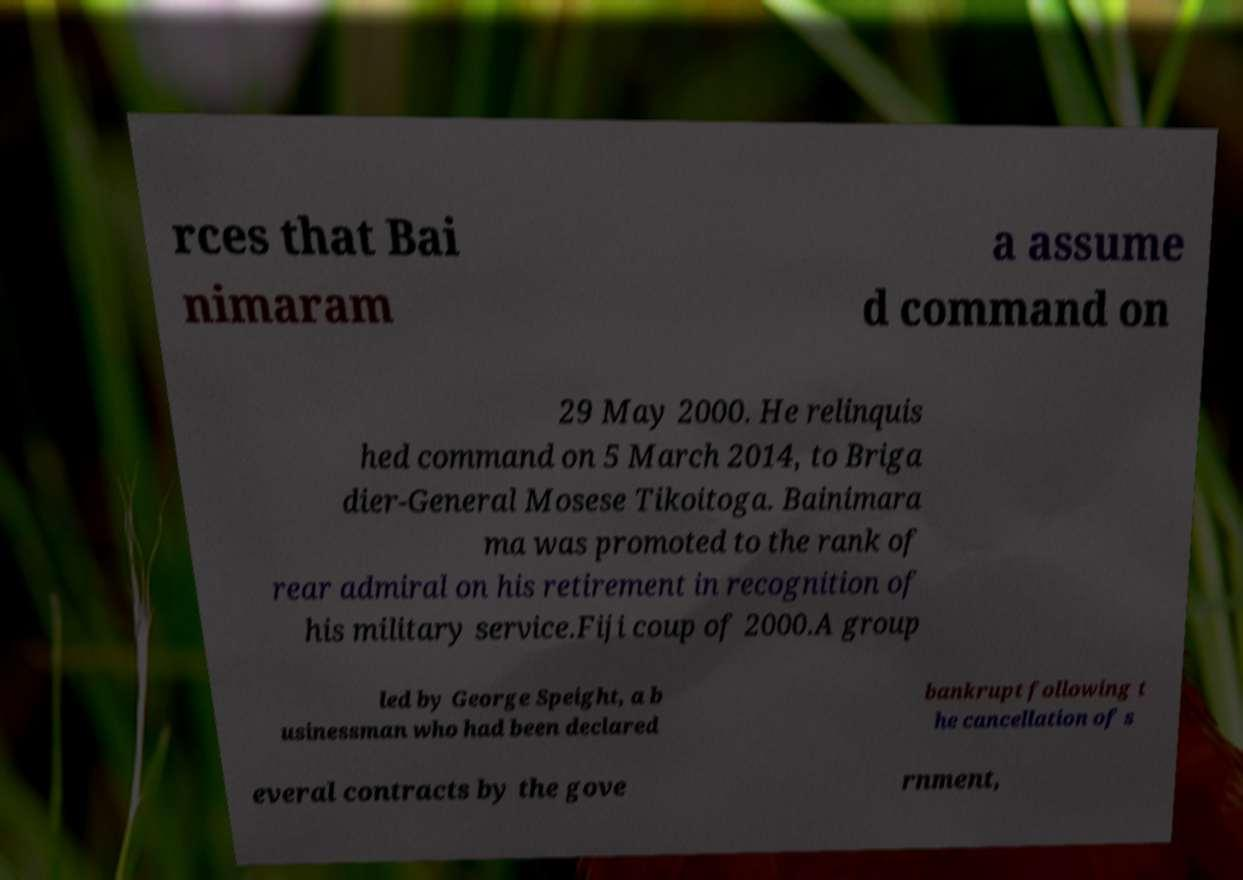What messages or text are displayed in this image? I need them in a readable, typed format. rces that Bai nimaram a assume d command on 29 May 2000. He relinquis hed command on 5 March 2014, to Briga dier-General Mosese Tikoitoga. Bainimara ma was promoted to the rank of rear admiral on his retirement in recognition of his military service.Fiji coup of 2000.A group led by George Speight, a b usinessman who had been declared bankrupt following t he cancellation of s everal contracts by the gove rnment, 